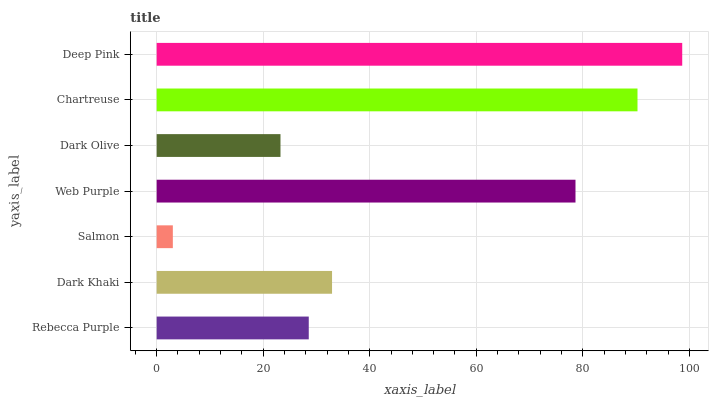Is Salmon the minimum?
Answer yes or no. Yes. Is Deep Pink the maximum?
Answer yes or no. Yes. Is Dark Khaki the minimum?
Answer yes or no. No. Is Dark Khaki the maximum?
Answer yes or no. No. Is Dark Khaki greater than Rebecca Purple?
Answer yes or no. Yes. Is Rebecca Purple less than Dark Khaki?
Answer yes or no. Yes. Is Rebecca Purple greater than Dark Khaki?
Answer yes or no. No. Is Dark Khaki less than Rebecca Purple?
Answer yes or no. No. Is Dark Khaki the high median?
Answer yes or no. Yes. Is Dark Khaki the low median?
Answer yes or no. Yes. Is Web Purple the high median?
Answer yes or no. No. Is Web Purple the low median?
Answer yes or no. No. 